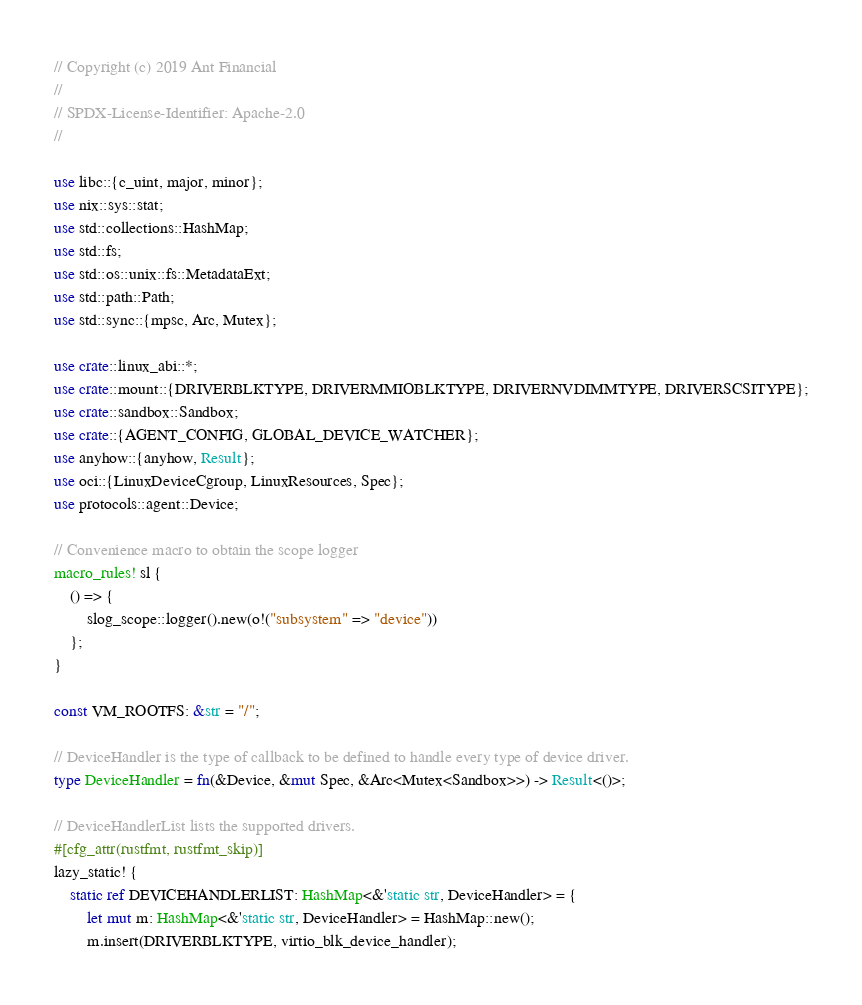Convert code to text. <code><loc_0><loc_0><loc_500><loc_500><_Rust_>// Copyright (c) 2019 Ant Financial
//
// SPDX-License-Identifier: Apache-2.0
//

use libc::{c_uint, major, minor};
use nix::sys::stat;
use std::collections::HashMap;
use std::fs;
use std::os::unix::fs::MetadataExt;
use std::path::Path;
use std::sync::{mpsc, Arc, Mutex};

use crate::linux_abi::*;
use crate::mount::{DRIVERBLKTYPE, DRIVERMMIOBLKTYPE, DRIVERNVDIMMTYPE, DRIVERSCSITYPE};
use crate::sandbox::Sandbox;
use crate::{AGENT_CONFIG, GLOBAL_DEVICE_WATCHER};
use anyhow::{anyhow, Result};
use oci::{LinuxDeviceCgroup, LinuxResources, Spec};
use protocols::agent::Device;

// Convenience macro to obtain the scope logger
macro_rules! sl {
    () => {
        slog_scope::logger().new(o!("subsystem" => "device"))
    };
}

const VM_ROOTFS: &str = "/";

// DeviceHandler is the type of callback to be defined to handle every type of device driver.
type DeviceHandler = fn(&Device, &mut Spec, &Arc<Mutex<Sandbox>>) -> Result<()>;

// DeviceHandlerList lists the supported drivers.
#[cfg_attr(rustfmt, rustfmt_skip)]
lazy_static! {
    static ref DEVICEHANDLERLIST: HashMap<&'static str, DeviceHandler> = {
        let mut m: HashMap<&'static str, DeviceHandler> = HashMap::new();
        m.insert(DRIVERBLKTYPE, virtio_blk_device_handler);</code> 